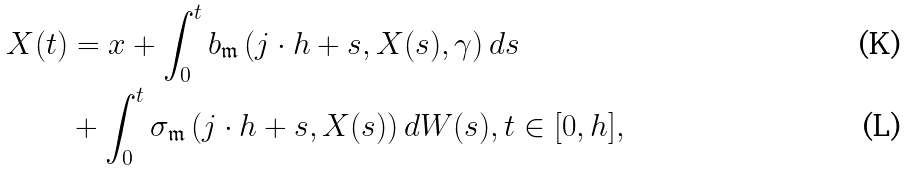<formula> <loc_0><loc_0><loc_500><loc_500>X ( t ) & = x + \int _ { 0 } ^ { t } b _ { \mathfrak { m } } \left ( j \cdot h + s , X ( s ) , \gamma \right ) d s \\ & + \int _ { 0 } ^ { t } \sigma _ { \mathfrak { m } } \left ( j \cdot h + s , X ( s ) \right ) d W ( s ) , t \in [ 0 , h ] ,</formula> 